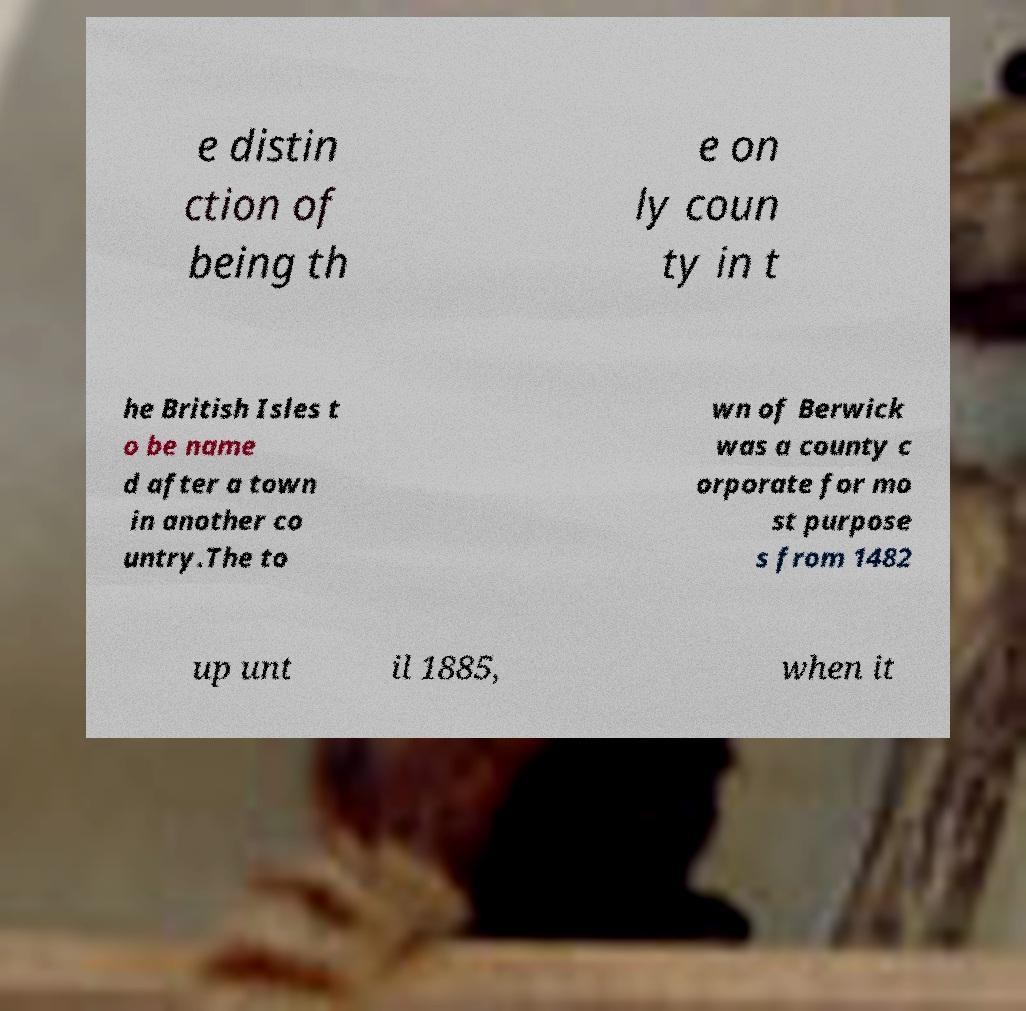Can you read and provide the text displayed in the image?This photo seems to have some interesting text. Can you extract and type it out for me? e distin ction of being th e on ly coun ty in t he British Isles t o be name d after a town in another co untry.The to wn of Berwick was a county c orporate for mo st purpose s from 1482 up unt il 1885, when it 